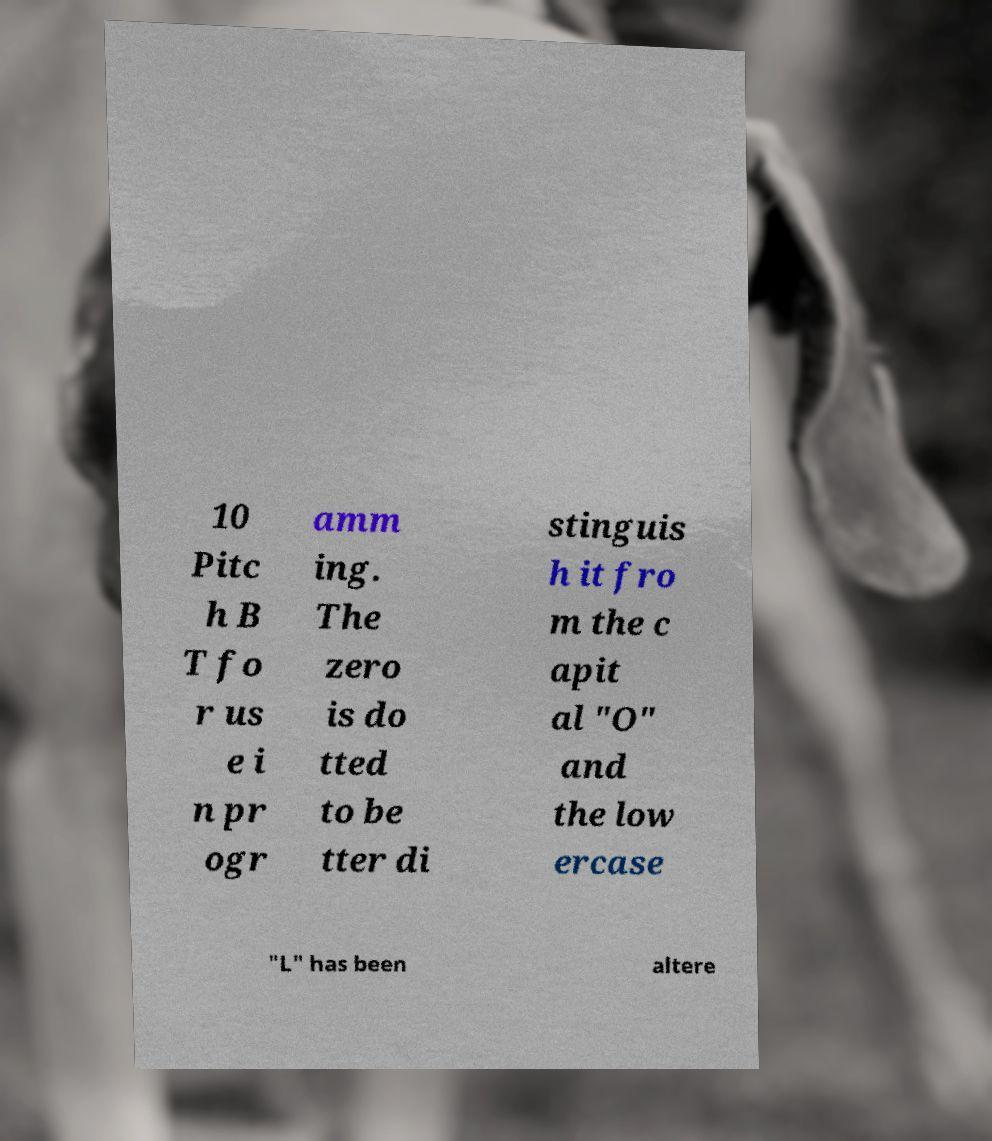Please identify and transcribe the text found in this image. 10 Pitc h B T fo r us e i n pr ogr amm ing. The zero is do tted to be tter di stinguis h it fro m the c apit al "O" and the low ercase "L" has been altere 